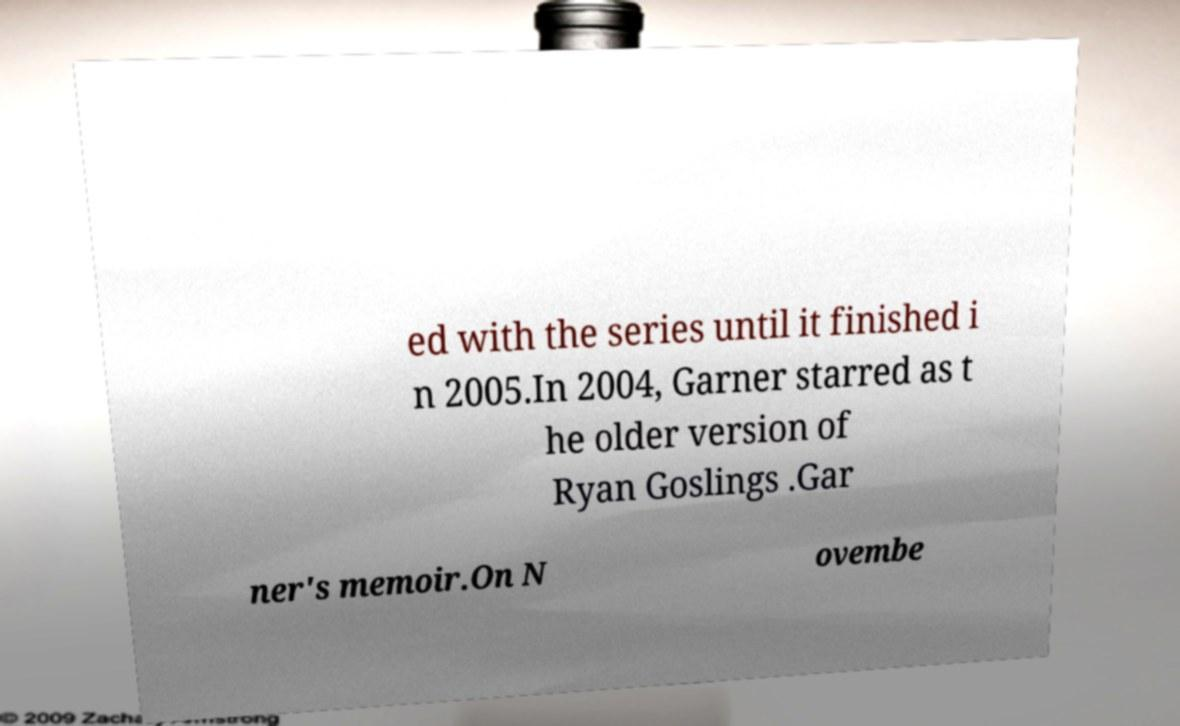There's text embedded in this image that I need extracted. Can you transcribe it verbatim? ed with the series until it finished i n 2005.In 2004, Garner starred as t he older version of Ryan Goslings .Gar ner's memoir.On N ovembe 